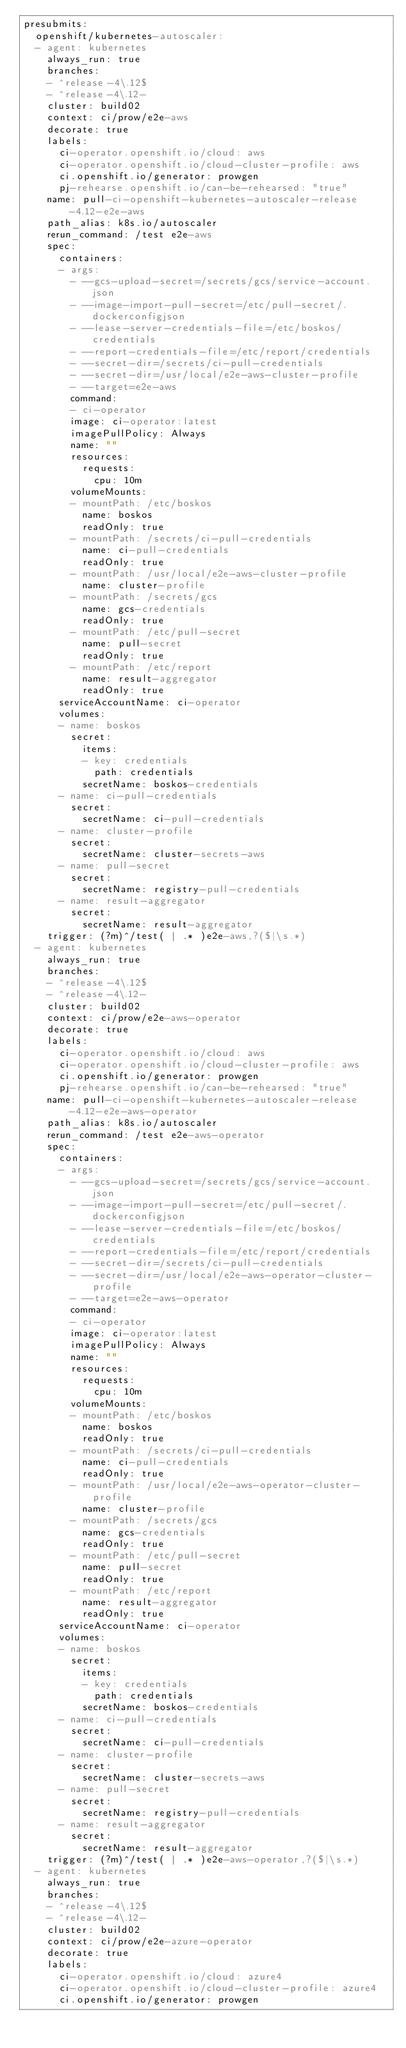Convert code to text. <code><loc_0><loc_0><loc_500><loc_500><_YAML_>presubmits:
  openshift/kubernetes-autoscaler:
  - agent: kubernetes
    always_run: true
    branches:
    - ^release-4\.12$
    - ^release-4\.12-
    cluster: build02
    context: ci/prow/e2e-aws
    decorate: true
    labels:
      ci-operator.openshift.io/cloud: aws
      ci-operator.openshift.io/cloud-cluster-profile: aws
      ci.openshift.io/generator: prowgen
      pj-rehearse.openshift.io/can-be-rehearsed: "true"
    name: pull-ci-openshift-kubernetes-autoscaler-release-4.12-e2e-aws
    path_alias: k8s.io/autoscaler
    rerun_command: /test e2e-aws
    spec:
      containers:
      - args:
        - --gcs-upload-secret=/secrets/gcs/service-account.json
        - --image-import-pull-secret=/etc/pull-secret/.dockerconfigjson
        - --lease-server-credentials-file=/etc/boskos/credentials
        - --report-credentials-file=/etc/report/credentials
        - --secret-dir=/secrets/ci-pull-credentials
        - --secret-dir=/usr/local/e2e-aws-cluster-profile
        - --target=e2e-aws
        command:
        - ci-operator
        image: ci-operator:latest
        imagePullPolicy: Always
        name: ""
        resources:
          requests:
            cpu: 10m
        volumeMounts:
        - mountPath: /etc/boskos
          name: boskos
          readOnly: true
        - mountPath: /secrets/ci-pull-credentials
          name: ci-pull-credentials
          readOnly: true
        - mountPath: /usr/local/e2e-aws-cluster-profile
          name: cluster-profile
        - mountPath: /secrets/gcs
          name: gcs-credentials
          readOnly: true
        - mountPath: /etc/pull-secret
          name: pull-secret
          readOnly: true
        - mountPath: /etc/report
          name: result-aggregator
          readOnly: true
      serviceAccountName: ci-operator
      volumes:
      - name: boskos
        secret:
          items:
          - key: credentials
            path: credentials
          secretName: boskos-credentials
      - name: ci-pull-credentials
        secret:
          secretName: ci-pull-credentials
      - name: cluster-profile
        secret:
          secretName: cluster-secrets-aws
      - name: pull-secret
        secret:
          secretName: registry-pull-credentials
      - name: result-aggregator
        secret:
          secretName: result-aggregator
    trigger: (?m)^/test( | .* )e2e-aws,?($|\s.*)
  - agent: kubernetes
    always_run: true
    branches:
    - ^release-4\.12$
    - ^release-4\.12-
    cluster: build02
    context: ci/prow/e2e-aws-operator
    decorate: true
    labels:
      ci-operator.openshift.io/cloud: aws
      ci-operator.openshift.io/cloud-cluster-profile: aws
      ci.openshift.io/generator: prowgen
      pj-rehearse.openshift.io/can-be-rehearsed: "true"
    name: pull-ci-openshift-kubernetes-autoscaler-release-4.12-e2e-aws-operator
    path_alias: k8s.io/autoscaler
    rerun_command: /test e2e-aws-operator
    spec:
      containers:
      - args:
        - --gcs-upload-secret=/secrets/gcs/service-account.json
        - --image-import-pull-secret=/etc/pull-secret/.dockerconfigjson
        - --lease-server-credentials-file=/etc/boskos/credentials
        - --report-credentials-file=/etc/report/credentials
        - --secret-dir=/secrets/ci-pull-credentials
        - --secret-dir=/usr/local/e2e-aws-operator-cluster-profile
        - --target=e2e-aws-operator
        command:
        - ci-operator
        image: ci-operator:latest
        imagePullPolicy: Always
        name: ""
        resources:
          requests:
            cpu: 10m
        volumeMounts:
        - mountPath: /etc/boskos
          name: boskos
          readOnly: true
        - mountPath: /secrets/ci-pull-credentials
          name: ci-pull-credentials
          readOnly: true
        - mountPath: /usr/local/e2e-aws-operator-cluster-profile
          name: cluster-profile
        - mountPath: /secrets/gcs
          name: gcs-credentials
          readOnly: true
        - mountPath: /etc/pull-secret
          name: pull-secret
          readOnly: true
        - mountPath: /etc/report
          name: result-aggregator
          readOnly: true
      serviceAccountName: ci-operator
      volumes:
      - name: boskos
        secret:
          items:
          - key: credentials
            path: credentials
          secretName: boskos-credentials
      - name: ci-pull-credentials
        secret:
          secretName: ci-pull-credentials
      - name: cluster-profile
        secret:
          secretName: cluster-secrets-aws
      - name: pull-secret
        secret:
          secretName: registry-pull-credentials
      - name: result-aggregator
        secret:
          secretName: result-aggregator
    trigger: (?m)^/test( | .* )e2e-aws-operator,?($|\s.*)
  - agent: kubernetes
    always_run: true
    branches:
    - ^release-4\.12$
    - ^release-4\.12-
    cluster: build02
    context: ci/prow/e2e-azure-operator
    decorate: true
    labels:
      ci-operator.openshift.io/cloud: azure4
      ci-operator.openshift.io/cloud-cluster-profile: azure4
      ci.openshift.io/generator: prowgen</code> 